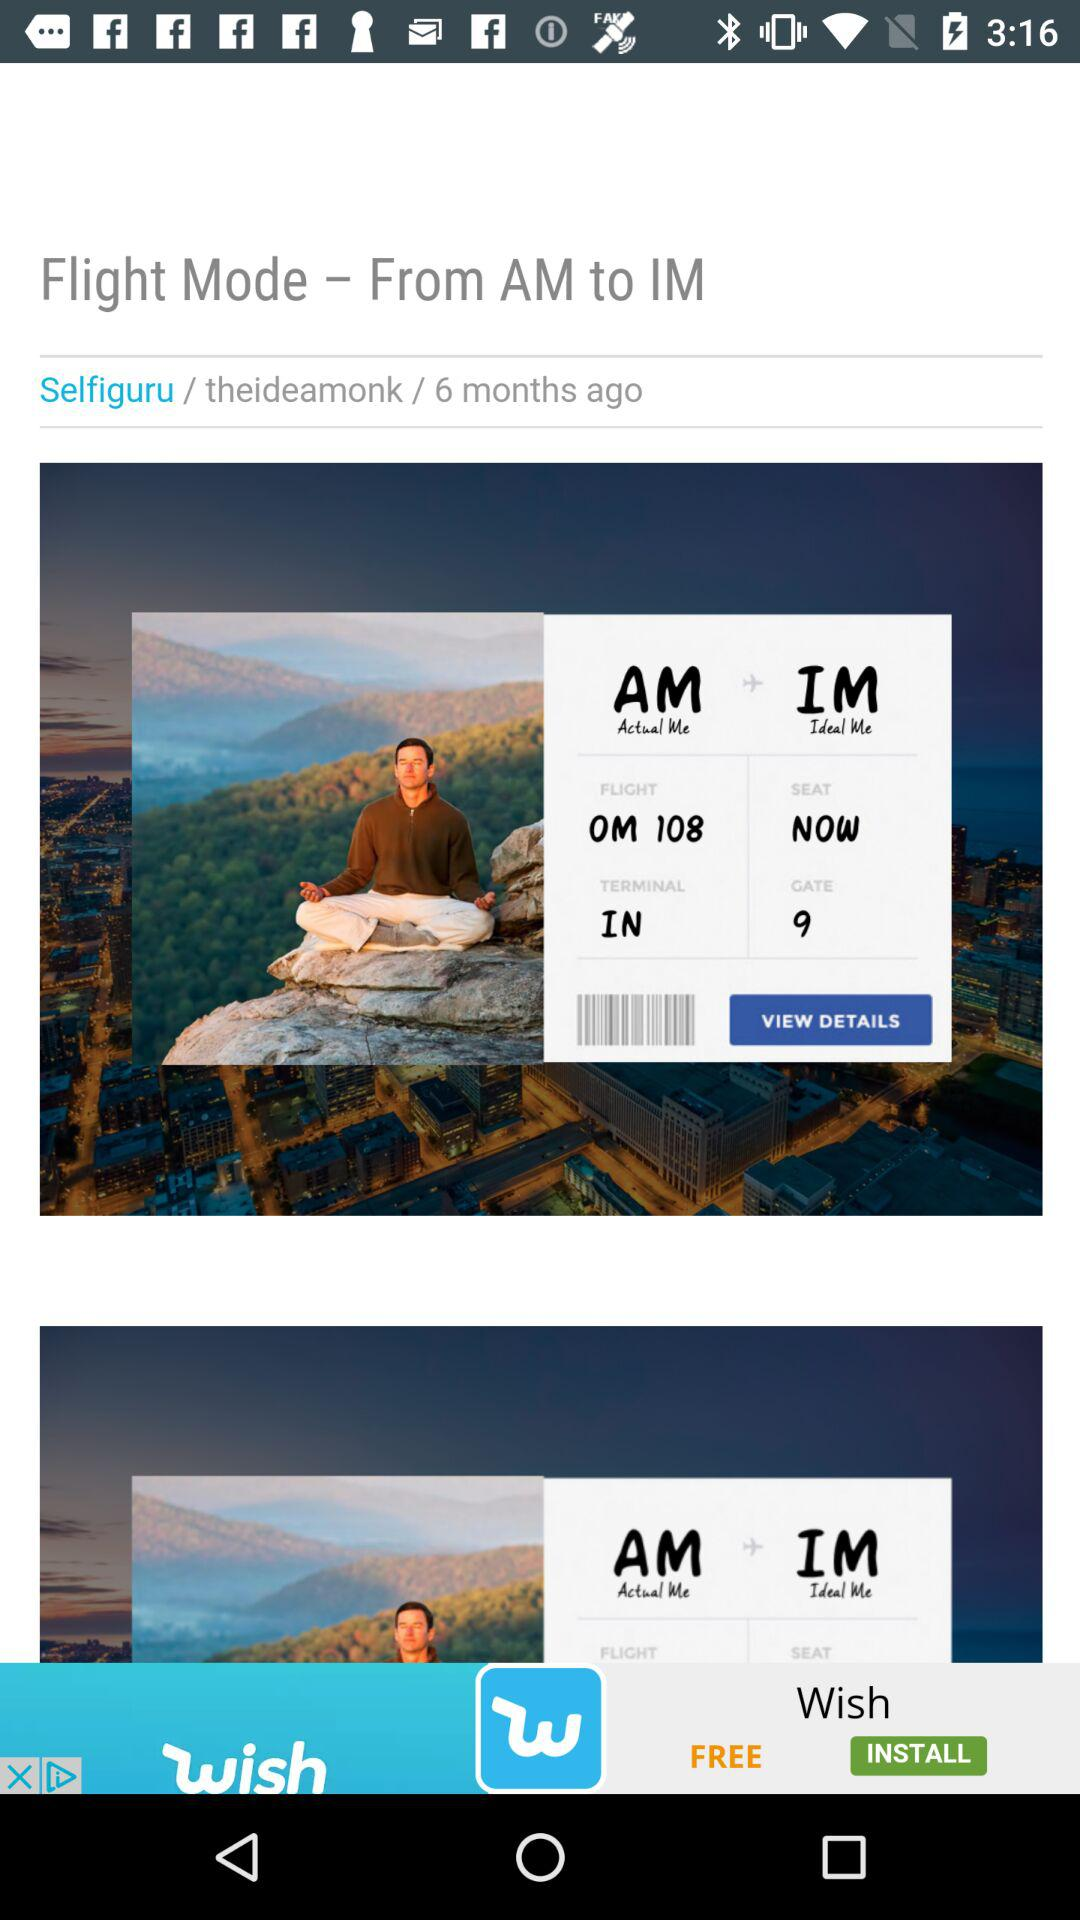What is the flight mode? The flight mode is "From AM to IM". 